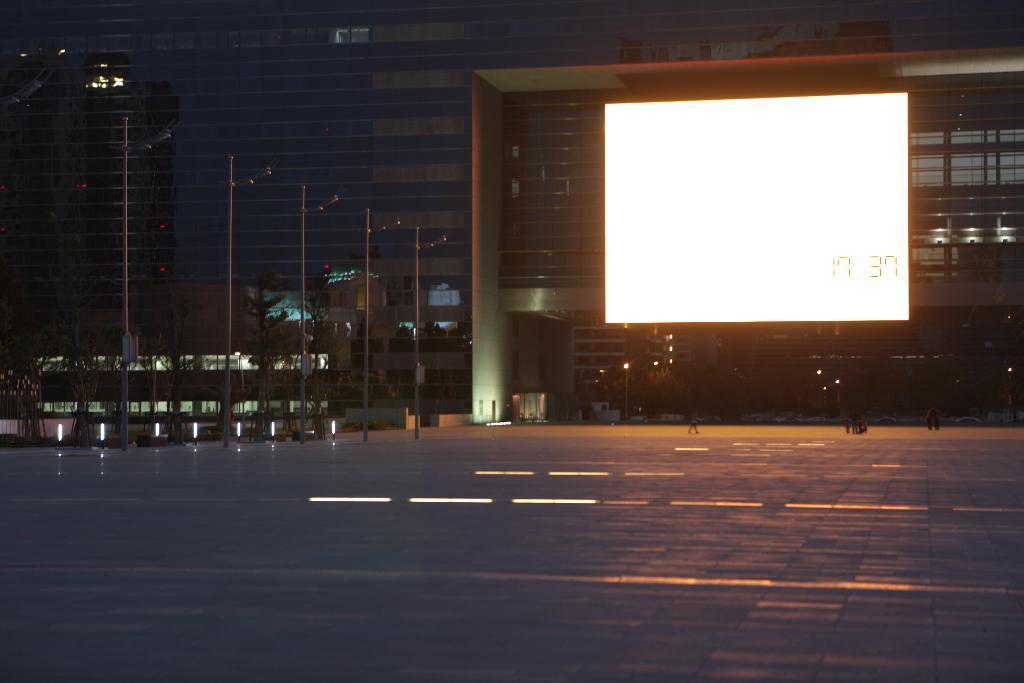Please provide a concise description of this image. In this image I can see the floor, few metal poles, a huge screen which is white in color and few persons standing on the floor. In the background I can see few trees, a building which is made of glass and few lights. 